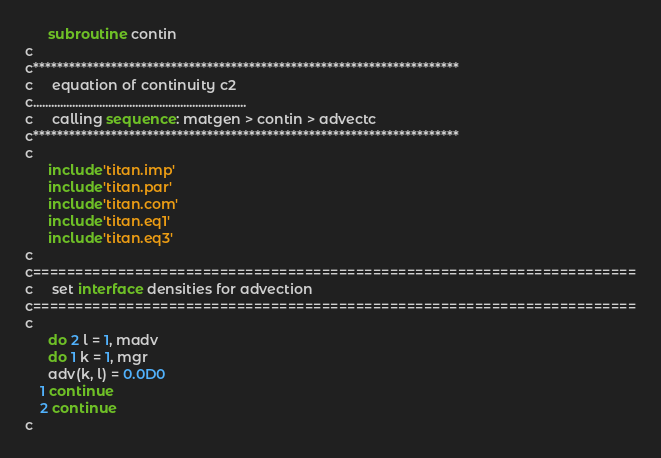Convert code to text. <code><loc_0><loc_0><loc_500><loc_500><_FORTRAN_>      subroutine contin
c
c***********************************************************************
c     equation of continuity c2
c.......................................................................
c     calling sequence: matgen > contin > advectc
c***********************************************************************
c
      include'titan.imp'
      include'titan.par'
      include'titan.com'
      include'titan.eq1'
      include'titan.eq3'
c
c=======================================================================
c     set interface densities for advection
c=======================================================================
c
      do 2 l = 1, madv
      do 1 k = 1, mgr
      adv(k, l) = 0.0D0
    1 continue
    2 continue
c</code> 